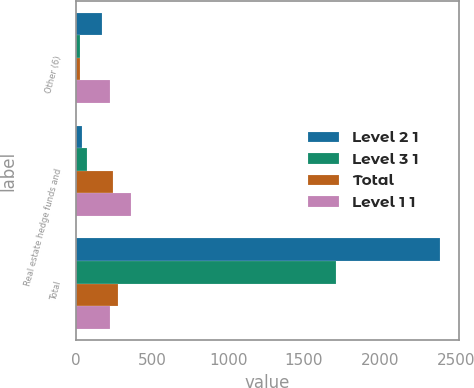Convert chart. <chart><loc_0><loc_0><loc_500><loc_500><stacked_bar_chart><ecel><fcel>Other (6)<fcel>Real estate hedge funds and<fcel>Total<nl><fcel>Level 2 1<fcel>171<fcel>41<fcel>2398<nl><fcel>Level 3 1<fcel>22<fcel>73<fcel>1711<nl><fcel>Total<fcel>28<fcel>245<fcel>273<nl><fcel>Level 1 1<fcel>221<fcel>359<fcel>221<nl></chart> 